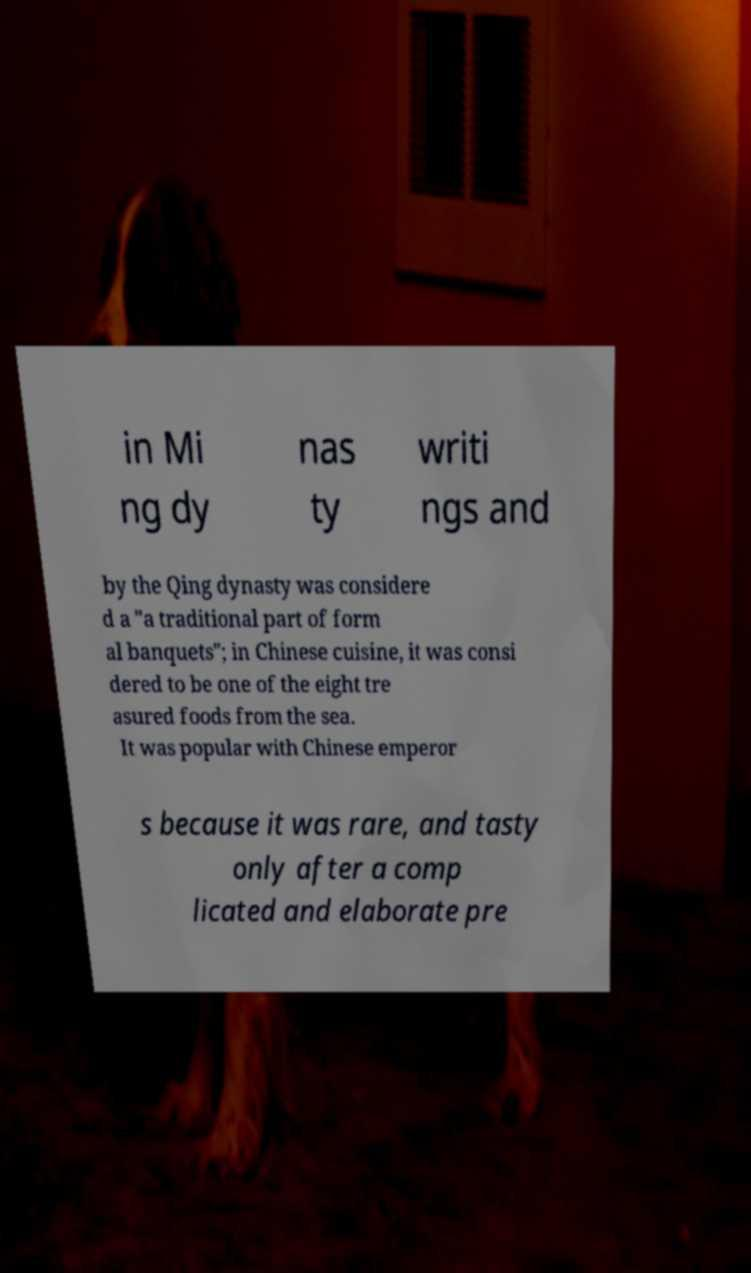Please identify and transcribe the text found in this image. in Mi ng dy nas ty writi ngs and by the Qing dynasty was considere d a "a traditional part of form al banquets"; in Chinese cuisine, it was consi dered to be one of the eight tre asured foods from the sea. It was popular with Chinese emperor s because it was rare, and tasty only after a comp licated and elaborate pre 